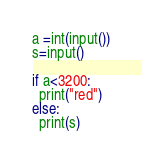<code> <loc_0><loc_0><loc_500><loc_500><_Python_>a =int(input())
s=input()

if a<3200:
  print("red")
else:
  print(s)</code> 